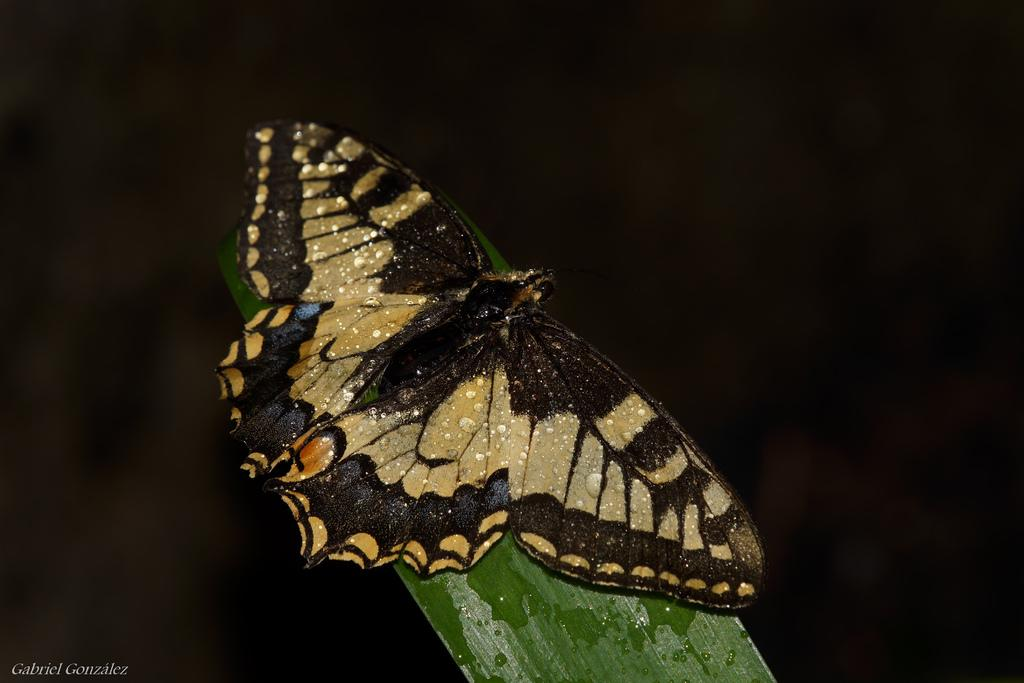What is the main subject of the image? There is a butterfly in the image. Where is the butterfly located? The butterfly is on a leaf. What is the color of the leaf? The leaf appears to be green in color. How would you describe the background of the image? The background of the image is dark. Can you see any yokes or farms in the image? No, there are no yokes or farms present in the image. Are there any mountains visible in the image? No, there are no mountains visible in the image. 